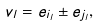Convert formula to latex. <formula><loc_0><loc_0><loc_500><loc_500>v _ { l } = e _ { i _ { l } } \pm e _ { j _ { l } } ,</formula> 